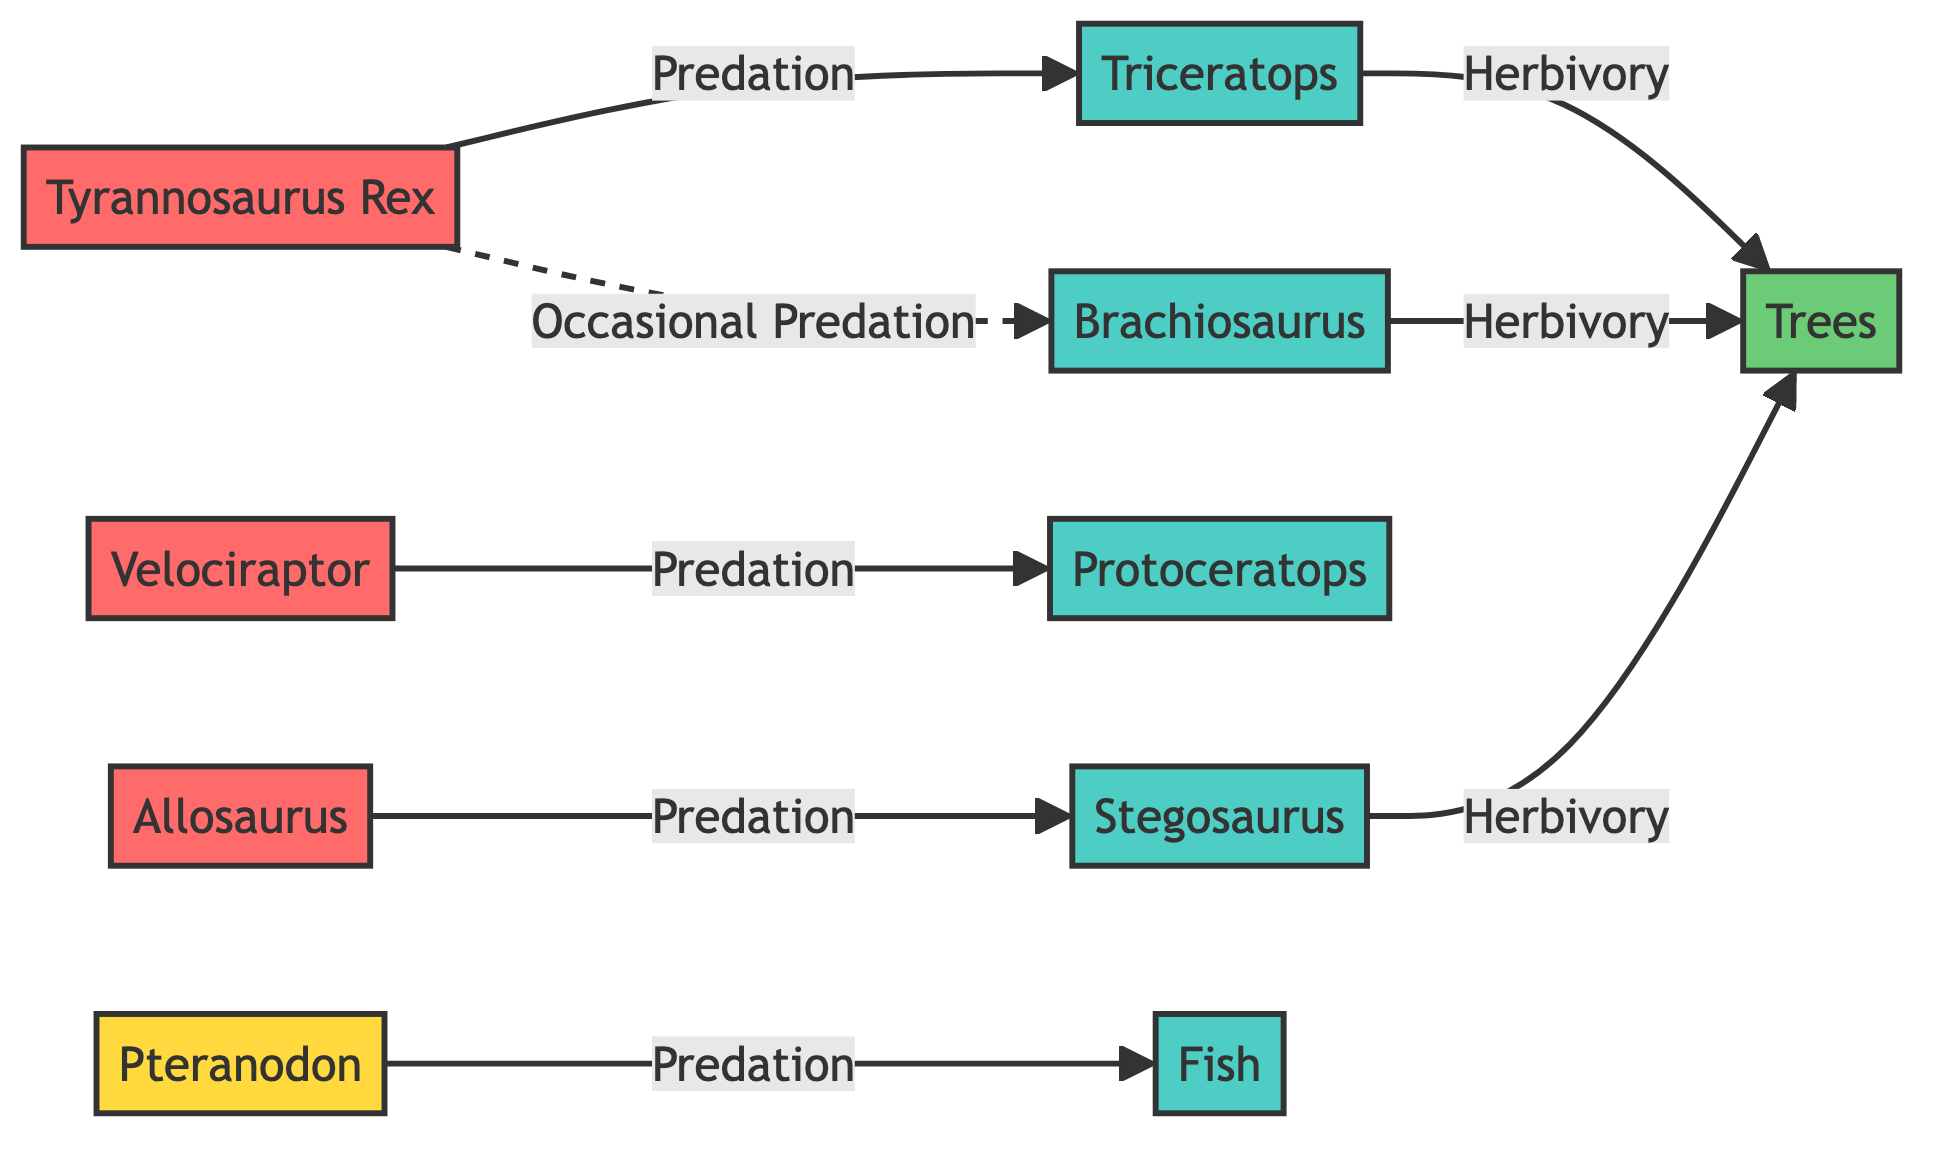What are the two predators specifically identified in the diagram? The diagram shows Tyrannosaurus Rex and Velociraptor as predators. They are visually categorized and connected to their prey, making it straightforward to identify them.
Answer: Tyrannosaurus Rex and Velociraptor How many prey items are depicted in the diagram? The diagram contains five distinct prey items: Triceratops, Protoceratops, Brachiosaurus, Stegosaurus, and Fish. Counting these nodes gives the total.
Answer: Five Which herbivore is occasionally preyed upon by the Tyrannosaurus Rex? The diagram indicates that the Tyrannosaurus Rex has an occasional predation link to the Brachiosaurus, shown by a dashed line denoting this relationship.
Answer: Brachiosaurus What type of interaction do Triceratops and Stegosaurus have with Trees? Both Triceratops and Stegosaurus exhibit herbivory towards Trees, as indicated by the arrows pointing to Trees from both prey nodes.
Answer: Herbivory Which predator is categorized as a scavenger? The diagram depicts Pteranodon as a predator and identifies it with a special coloring that denotes it as a scavenger, unlike the others.
Answer: Pteranodon What is the total number of distinct predators shown in the diagram? The diagram features four distinct predator nodes: Tyrannosaurus Rex, Velociraptor, Allosaurus, and Pteranodon. Counting them confirms the total is four.
Answer: Four Who preys on Stegosaurus according to the diagram? The diagram shows that Allosaurus preys on Stegosaurus, represented by a directional arrow connecting these two nodes.
Answer: Allosaurus How many species are indicated to engage in herbivory towards Trees? Three species are indicated to have herbivory interactions with Trees: Brachiosaurus, Triceratops, and Stegosaurus. A simple count of the arrows leading to Trees confirms this.
Answer: Three 